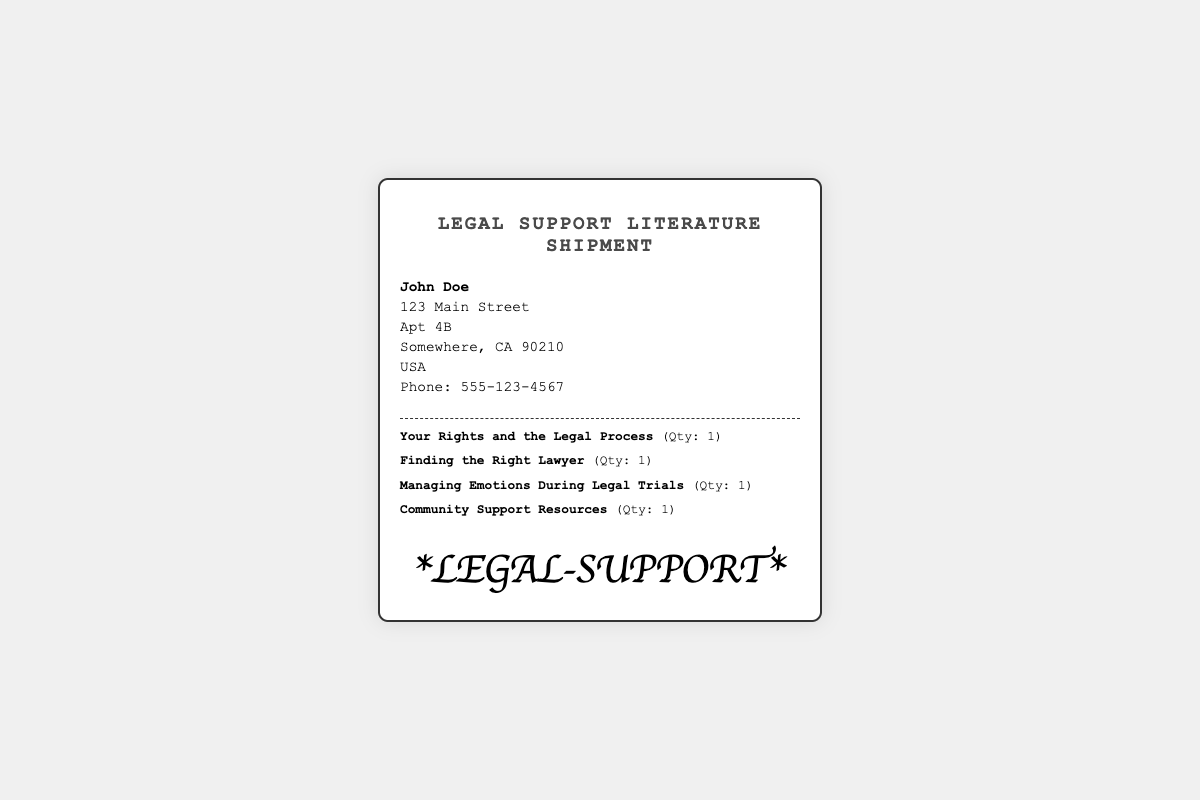What is the recipient's name? The recipient's name is prominently displayed at the top of the label.
Answer: John Doe Which item discusses emotional management? The item that addresses emotional management during legal trials is listed among the items.
Answer: Managing Emotions During Legal Trials How many items are included in the shipment? The total number of different items in the shipment can be counted from the itemized list provided.
Answer: 4 What is the address of the recipient? The full address of the recipient is provided in multiple lines.
Answer: 123 Main Street, Apt 4B, Somewhere, CA 90210, USA What is the telephone number for the recipient? The phone number is clearly indicated in the recipient information section.
Answer: 555-123-4567 What is the title of the shipment? The title of the shipment is found at the top of the label in bold font.
Answer: Legal Support Literature Shipment How many copies of "Finding the Right Lawyer" are there? The quantity of this specific item is mentioned alongside its title in the itemized list.
Answer: 1 What type of literature is included in the shipment? The type of items can be inferred from the titles listed under the itemized list.
Answer: Legal support literature 